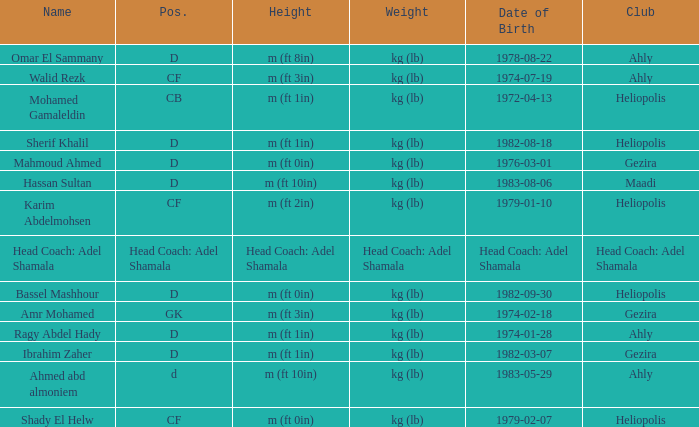What is Weight, when Club is "Ahly", and when Name is "Ragy Abdel Hady"? Kg (lb). 